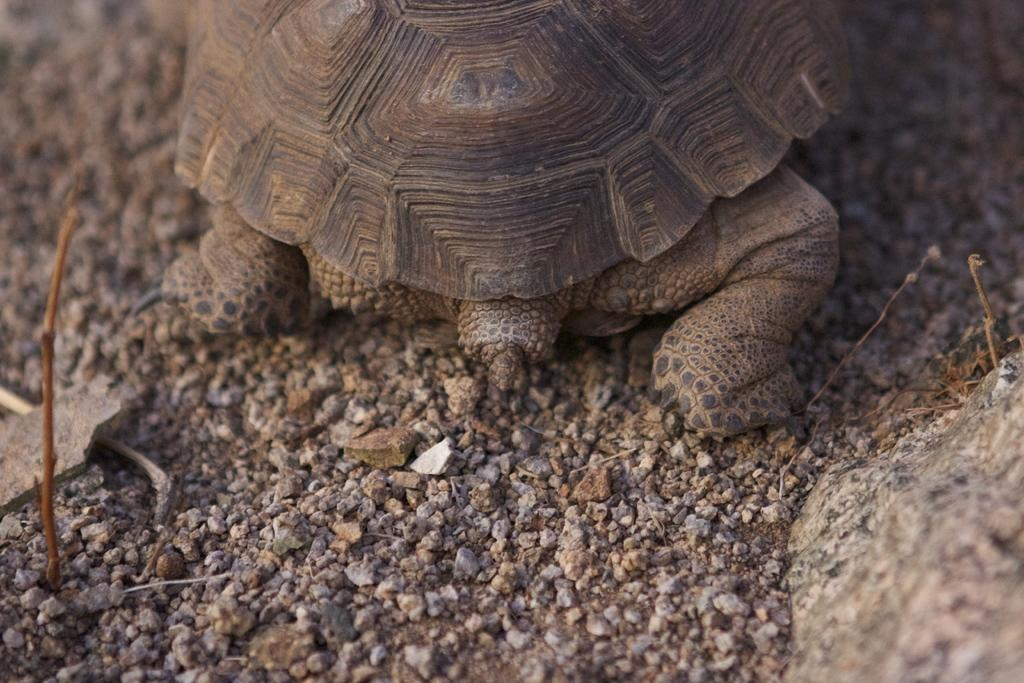What type of animal is in the image? There is a turtle in the image. What can be seen at the bottom of the image? There are stones at the bottom of the image. What other natural elements are present in the image? There are twigs in the image. How many girls are skating on the turtle's back in the image? There are no girls or skating activity present in the image. 